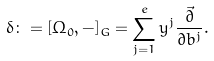Convert formula to latex. <formula><loc_0><loc_0><loc_500><loc_500>\delta \colon = [ \Omega _ { 0 } , - ] _ { G } = \sum _ { j = 1 } ^ { e } y ^ { j } \frac { \vec { \partial } } { \partial b ^ { j } } .</formula> 